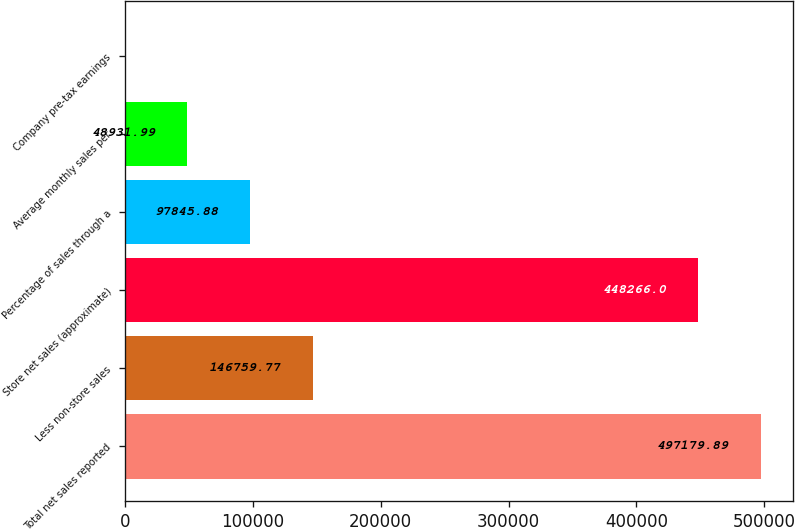<chart> <loc_0><loc_0><loc_500><loc_500><bar_chart><fcel>Total net sales reported<fcel>Less non-store sales<fcel>Store net sales (approximate)<fcel>Percentage of sales through a<fcel>Average monthly sales per<fcel>Company pre-tax earnings<nl><fcel>497180<fcel>146760<fcel>448266<fcel>97845.9<fcel>48932<fcel>18.1<nl></chart> 